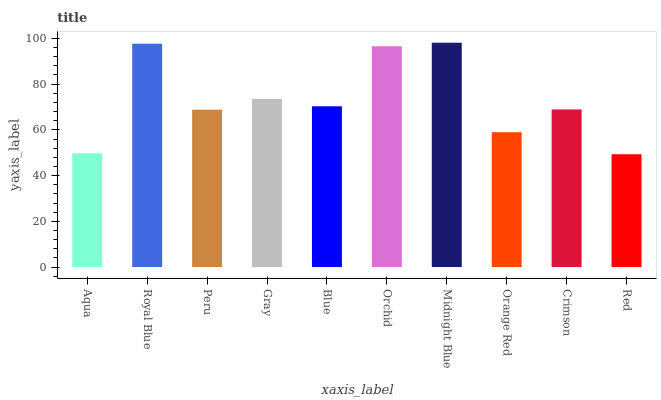Is Royal Blue the minimum?
Answer yes or no. No. Is Royal Blue the maximum?
Answer yes or no. No. Is Royal Blue greater than Aqua?
Answer yes or no. Yes. Is Aqua less than Royal Blue?
Answer yes or no. Yes. Is Aqua greater than Royal Blue?
Answer yes or no. No. Is Royal Blue less than Aqua?
Answer yes or no. No. Is Blue the high median?
Answer yes or no. Yes. Is Crimson the low median?
Answer yes or no. Yes. Is Peru the high median?
Answer yes or no. No. Is Orchid the low median?
Answer yes or no. No. 